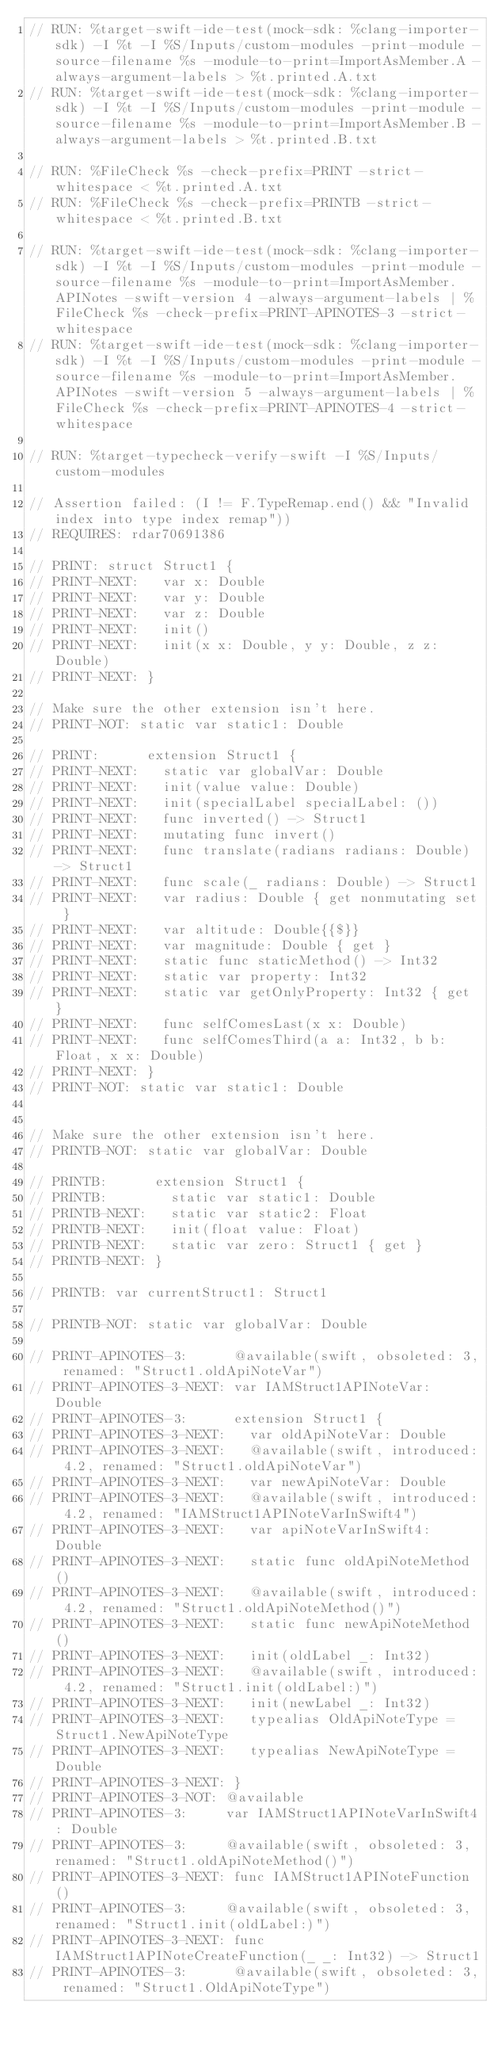<code> <loc_0><loc_0><loc_500><loc_500><_Swift_>// RUN: %target-swift-ide-test(mock-sdk: %clang-importer-sdk) -I %t -I %S/Inputs/custom-modules -print-module -source-filename %s -module-to-print=ImportAsMember.A -always-argument-labels > %t.printed.A.txt
// RUN: %target-swift-ide-test(mock-sdk: %clang-importer-sdk) -I %t -I %S/Inputs/custom-modules -print-module -source-filename %s -module-to-print=ImportAsMember.B -always-argument-labels > %t.printed.B.txt

// RUN: %FileCheck %s -check-prefix=PRINT -strict-whitespace < %t.printed.A.txt
// RUN: %FileCheck %s -check-prefix=PRINTB -strict-whitespace < %t.printed.B.txt

// RUN: %target-swift-ide-test(mock-sdk: %clang-importer-sdk) -I %t -I %S/Inputs/custom-modules -print-module -source-filename %s -module-to-print=ImportAsMember.APINotes -swift-version 4 -always-argument-labels | %FileCheck %s -check-prefix=PRINT-APINOTES-3 -strict-whitespace
// RUN: %target-swift-ide-test(mock-sdk: %clang-importer-sdk) -I %t -I %S/Inputs/custom-modules -print-module -source-filename %s -module-to-print=ImportAsMember.APINotes -swift-version 5 -always-argument-labels | %FileCheck %s -check-prefix=PRINT-APINOTES-4 -strict-whitespace

// RUN: %target-typecheck-verify-swift -I %S/Inputs/custom-modules

// Assertion failed: (I != F.TypeRemap.end() && "Invalid index into type index remap"))
// REQUIRES: rdar70691386

// PRINT: struct Struct1 {
// PRINT-NEXT:   var x: Double
// PRINT-NEXT:   var y: Double
// PRINT-NEXT:   var z: Double
// PRINT-NEXT:   init()
// PRINT-NEXT:   init(x x: Double, y y: Double, z z: Double)
// PRINT-NEXT: }

// Make sure the other extension isn't here.
// PRINT-NOT: static var static1: Double

// PRINT:      extension Struct1 {
// PRINT-NEXT:   static var globalVar: Double
// PRINT-NEXT:   init(value value: Double)
// PRINT-NEXT:   init(specialLabel specialLabel: ())
// PRINT-NEXT:   func inverted() -> Struct1
// PRINT-NEXT:   mutating func invert()
// PRINT-NEXT:   func translate(radians radians: Double) -> Struct1
// PRINT-NEXT:   func scale(_ radians: Double) -> Struct1
// PRINT-NEXT:   var radius: Double { get nonmutating set }
// PRINT-NEXT:   var altitude: Double{{$}}
// PRINT-NEXT:   var magnitude: Double { get }
// PRINT-NEXT:   static func staticMethod() -> Int32
// PRINT-NEXT:   static var property: Int32
// PRINT-NEXT:   static var getOnlyProperty: Int32 { get }
// PRINT-NEXT:   func selfComesLast(x x: Double)
// PRINT-NEXT:   func selfComesThird(a a: Int32, b b: Float, x x: Double)
// PRINT-NEXT: }
// PRINT-NOT: static var static1: Double


// Make sure the other extension isn't here.
// PRINTB-NOT: static var globalVar: Double

// PRINTB:      extension Struct1 {
// PRINTB:        static var static1: Double
// PRINTB-NEXT:   static var static2: Float
// PRINTB-NEXT:   init(float value: Float)
// PRINTB-NEXT:   static var zero: Struct1 { get }
// PRINTB-NEXT: }

// PRINTB: var currentStruct1: Struct1

// PRINTB-NOT: static var globalVar: Double

// PRINT-APINOTES-3:      @available(swift, obsoleted: 3, renamed: "Struct1.oldApiNoteVar")
// PRINT-APINOTES-3-NEXT: var IAMStruct1APINoteVar: Double
// PRINT-APINOTES-3:      extension Struct1 {
// PRINT-APINOTES-3-NEXT:   var oldApiNoteVar: Double
// PRINT-APINOTES-3-NEXT:   @available(swift, introduced: 4.2, renamed: "Struct1.oldApiNoteVar")
// PRINT-APINOTES-3-NEXT:   var newApiNoteVar: Double
// PRINT-APINOTES-3-NEXT:   @available(swift, introduced: 4.2, renamed: "IAMStruct1APINoteVarInSwift4")
// PRINT-APINOTES-3-NEXT:   var apiNoteVarInSwift4: Double
// PRINT-APINOTES-3-NEXT:   static func oldApiNoteMethod()
// PRINT-APINOTES-3-NEXT:   @available(swift, introduced: 4.2, renamed: "Struct1.oldApiNoteMethod()")
// PRINT-APINOTES-3-NEXT:   static func newApiNoteMethod()
// PRINT-APINOTES-3-NEXT:   init(oldLabel _: Int32)
// PRINT-APINOTES-3-NEXT:   @available(swift, introduced: 4.2, renamed: "Struct1.init(oldLabel:)")
// PRINT-APINOTES-3-NEXT:   init(newLabel _: Int32)
// PRINT-APINOTES-3-NEXT:   typealias OldApiNoteType = Struct1.NewApiNoteType
// PRINT-APINOTES-3-NEXT:   typealias NewApiNoteType = Double
// PRINT-APINOTES-3-NEXT: }
// PRINT-APINOTES-3-NOT: @available
// PRINT-APINOTES-3:     var IAMStruct1APINoteVarInSwift4: Double
// PRINT-APINOTES-3:     @available(swift, obsoleted: 3, renamed: "Struct1.oldApiNoteMethod()")
// PRINT-APINOTES-3-NEXT: func IAMStruct1APINoteFunction()
// PRINT-APINOTES-3:     @available(swift, obsoleted: 3, renamed: "Struct1.init(oldLabel:)")
// PRINT-APINOTES-3-NEXT: func IAMStruct1APINoteCreateFunction(_ _: Int32) -> Struct1
// PRINT-APINOTES-3:      @available(swift, obsoleted: 3, renamed: "Struct1.OldApiNoteType")</code> 